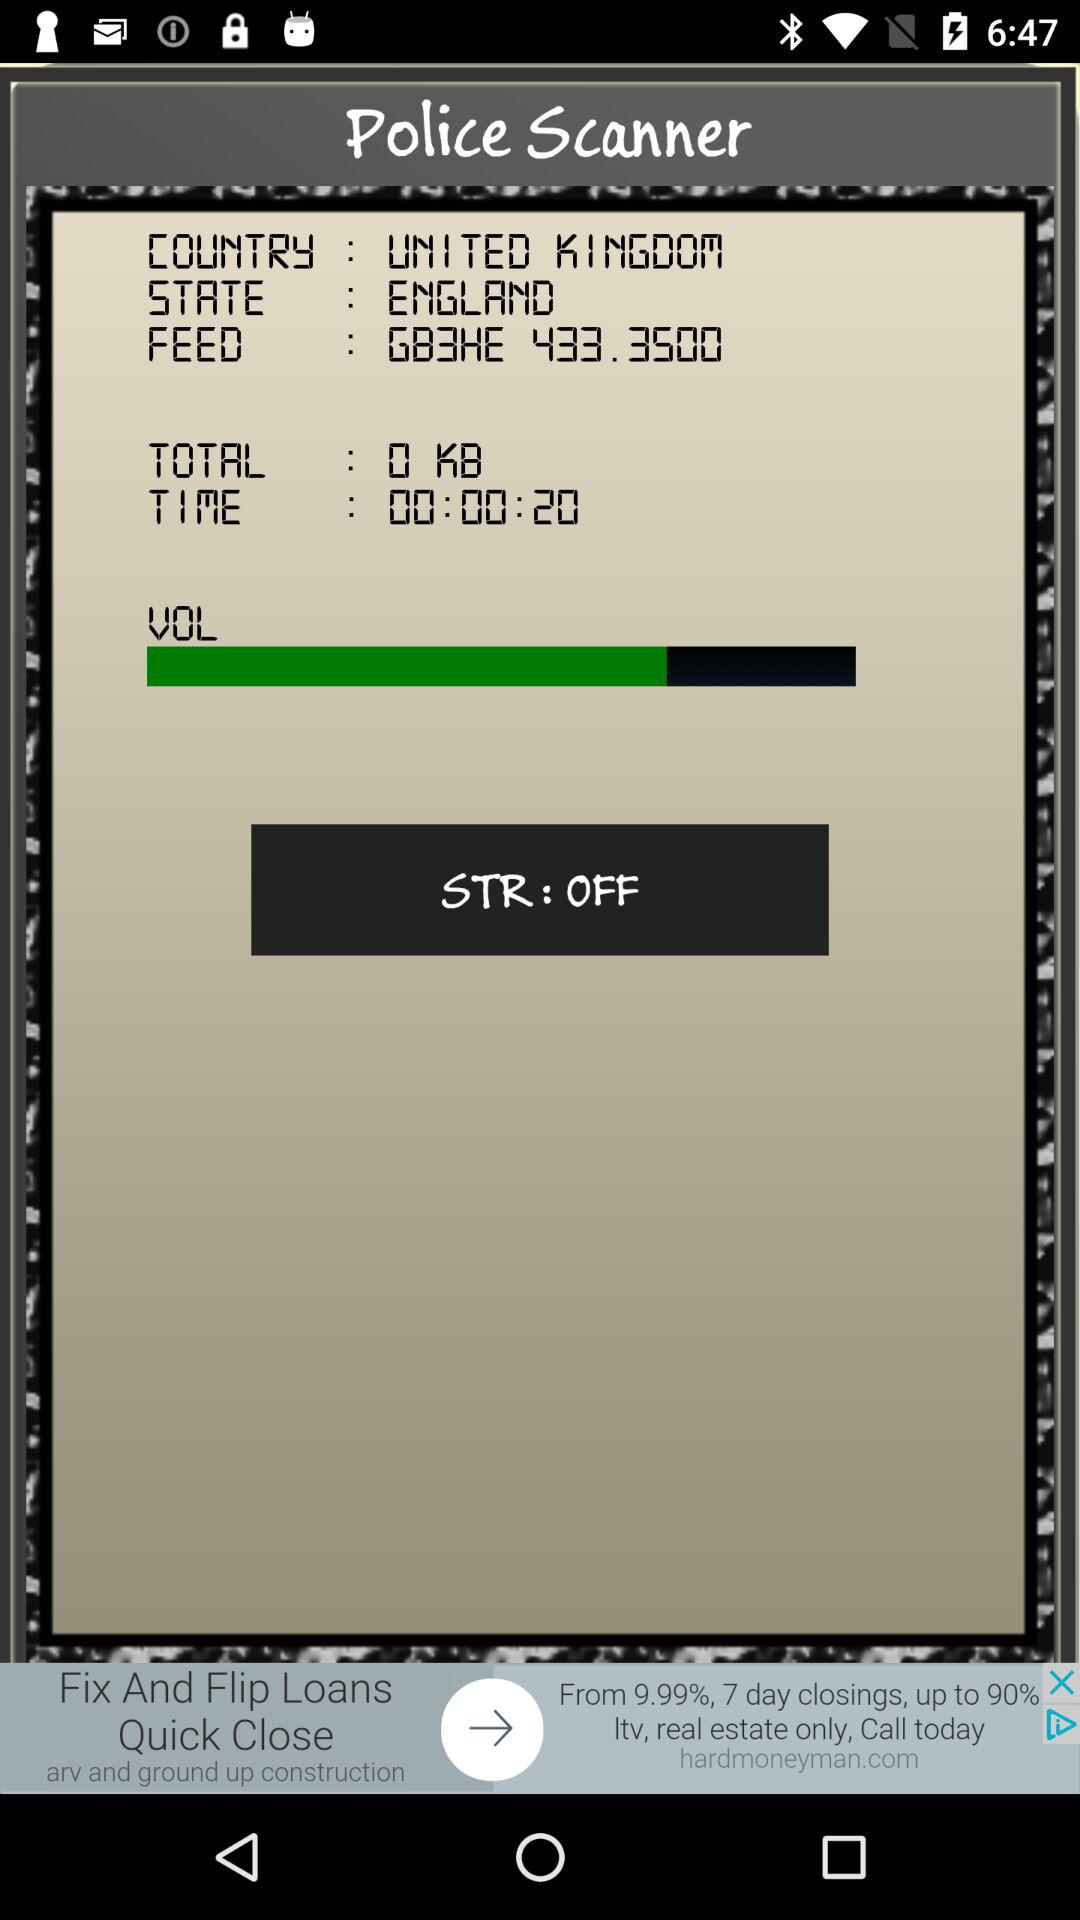What is the given time? The given time is 00:00:20. 